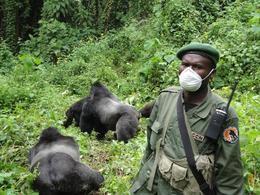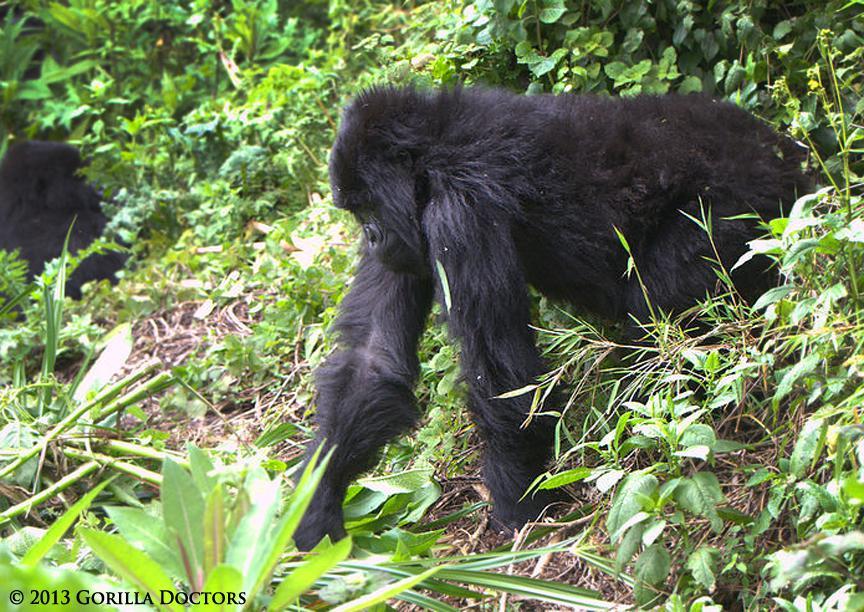The first image is the image on the left, the second image is the image on the right. For the images displayed, is the sentence "There are two gorillas in the pair of images." factually correct? Answer yes or no. No. The first image is the image on the left, the second image is the image on the right. Considering the images on both sides, is "The left image contains exactly one gorilla." valid? Answer yes or no. No. 